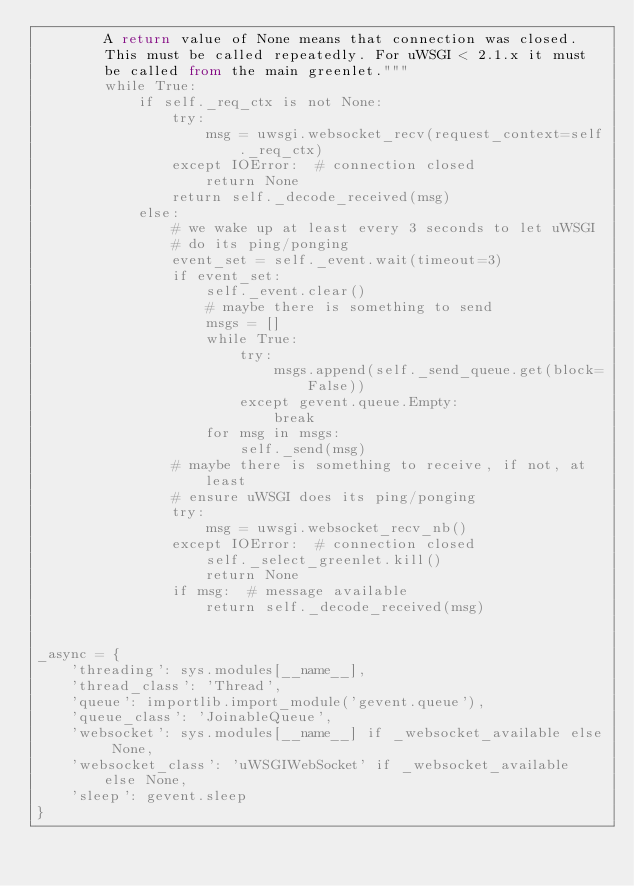Convert code to text. <code><loc_0><loc_0><loc_500><loc_500><_Python_>        A return value of None means that connection was closed.
        This must be called repeatedly. For uWSGI < 2.1.x it must
        be called from the main greenlet."""
        while True:
            if self._req_ctx is not None:
                try:
                    msg = uwsgi.websocket_recv(request_context=self._req_ctx)
                except IOError:  # connection closed
                    return None
                return self._decode_received(msg)
            else:
                # we wake up at least every 3 seconds to let uWSGI
                # do its ping/ponging
                event_set = self._event.wait(timeout=3)
                if event_set:
                    self._event.clear()
                    # maybe there is something to send
                    msgs = []
                    while True:
                        try:
                            msgs.append(self._send_queue.get(block=False))
                        except gevent.queue.Empty:
                            break
                    for msg in msgs:
                        self._send(msg)
                # maybe there is something to receive, if not, at least
                # ensure uWSGI does its ping/ponging
                try:
                    msg = uwsgi.websocket_recv_nb()
                except IOError:  # connection closed
                    self._select_greenlet.kill()
                    return None
                if msg:  # message available
                    return self._decode_received(msg)


_async = {
    'threading': sys.modules[__name__],
    'thread_class': 'Thread',
    'queue': importlib.import_module('gevent.queue'),
    'queue_class': 'JoinableQueue',
    'websocket': sys.modules[__name__] if _websocket_available else None,
    'websocket_class': 'uWSGIWebSocket' if _websocket_available else None,
    'sleep': gevent.sleep
}
</code> 